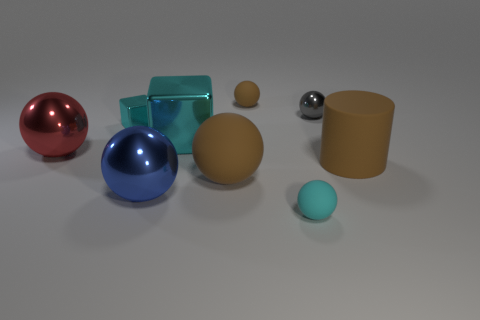The big rubber thing to the right of the brown rubber thing that is behind the ball that is right of the tiny cyan ball is what color?
Your answer should be very brief. Brown. Is there any other thing that has the same color as the large metallic cube?
Your answer should be compact. Yes. Do the brown cylinder and the gray metal object have the same size?
Your answer should be very brief. No. How many things are either spheres that are right of the tiny cyan metallic thing or metallic things that are in front of the cylinder?
Ensure brevity in your answer.  5. What is the material of the brown thing that is on the left side of the tiny rubber object that is behind the rubber cylinder?
Ensure brevity in your answer.  Rubber. How many other things are the same material as the big cube?
Your response must be concise. 4. Do the gray shiny thing and the large cyan object have the same shape?
Keep it short and to the point. No. What size is the cyan block that is right of the blue sphere?
Ensure brevity in your answer.  Large. There is a cyan matte object; is it the same size as the red metallic ball that is left of the small gray metal sphere?
Ensure brevity in your answer.  No. Are there fewer large spheres that are in front of the red metal sphere than spheres?
Your response must be concise. Yes. 